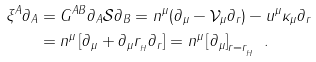Convert formula to latex. <formula><loc_0><loc_0><loc_500><loc_500>\xi ^ { A } \partial _ { A } & = { G } ^ { A B } \partial _ { A } \mathcal { S } \partial _ { B } = n ^ { \mu } ( \partial _ { \mu } - \mathcal { V } _ { \mu } \partial _ { r } ) - u ^ { \mu } \kappa _ { \mu } \partial _ { r } \\ & = n ^ { \mu } \left [ \partial _ { \mu } + \partial _ { \mu } r _ { _ { H } } \partial _ { r } \right ] = n ^ { \mu } \left [ \partial _ { \mu } \right ] _ { r = r _ { _ { H } } } \ .</formula> 